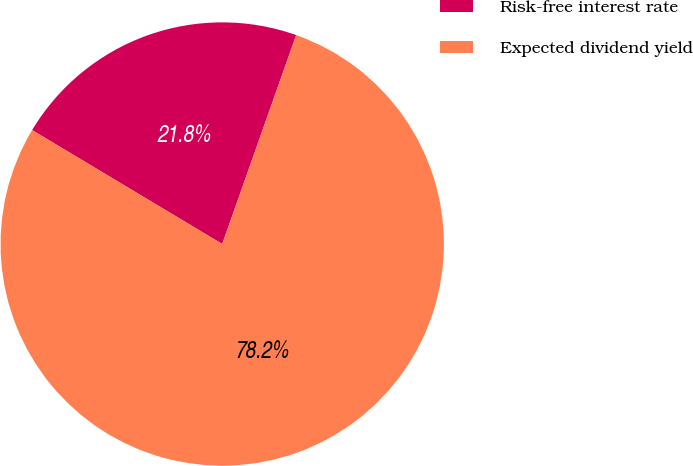Convert chart to OTSL. <chart><loc_0><loc_0><loc_500><loc_500><pie_chart><fcel>Risk-free interest rate<fcel>Expected dividend yield<nl><fcel>21.82%<fcel>78.18%<nl></chart> 